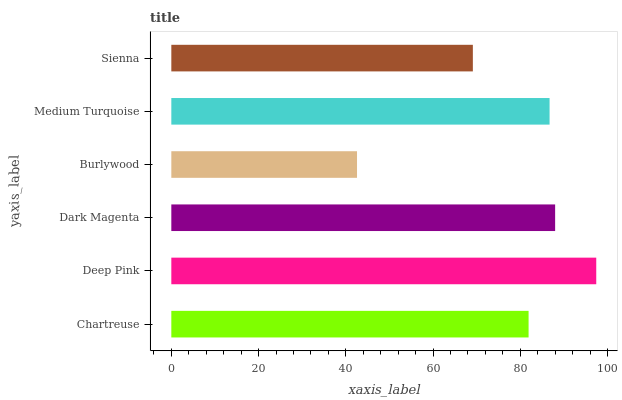Is Burlywood the minimum?
Answer yes or no. Yes. Is Deep Pink the maximum?
Answer yes or no. Yes. Is Dark Magenta the minimum?
Answer yes or no. No. Is Dark Magenta the maximum?
Answer yes or no. No. Is Deep Pink greater than Dark Magenta?
Answer yes or no. Yes. Is Dark Magenta less than Deep Pink?
Answer yes or no. Yes. Is Dark Magenta greater than Deep Pink?
Answer yes or no. No. Is Deep Pink less than Dark Magenta?
Answer yes or no. No. Is Medium Turquoise the high median?
Answer yes or no. Yes. Is Chartreuse the low median?
Answer yes or no. Yes. Is Chartreuse the high median?
Answer yes or no. No. Is Dark Magenta the low median?
Answer yes or no. No. 